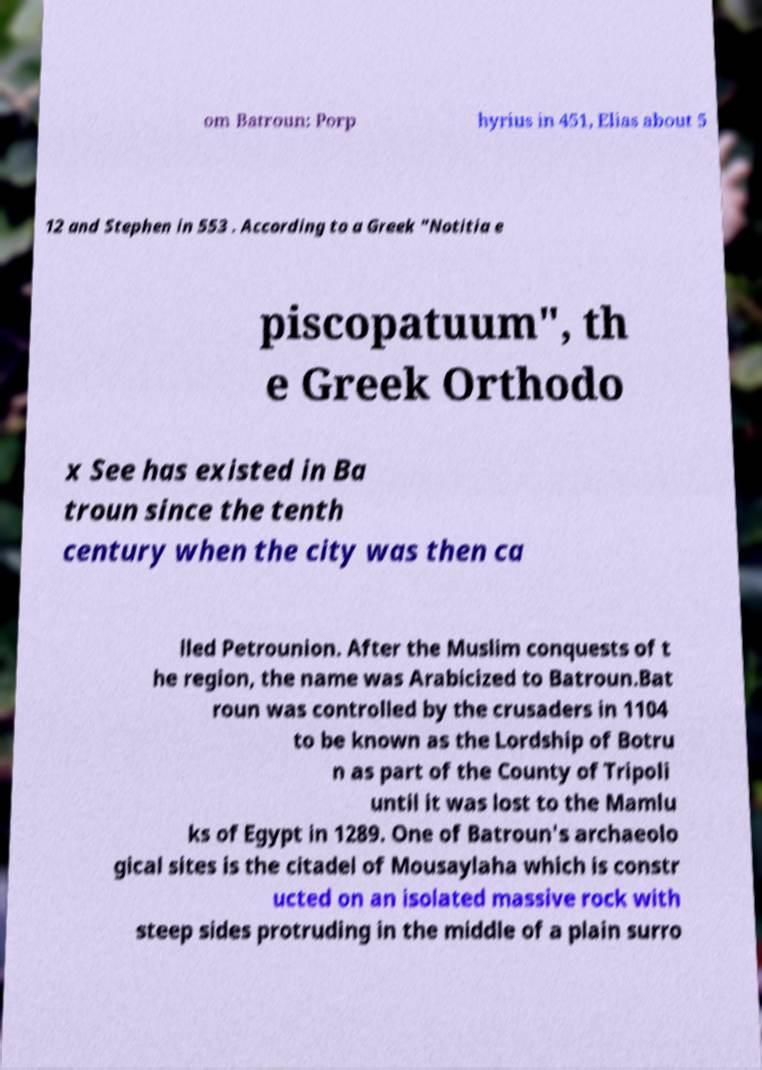Could you assist in decoding the text presented in this image and type it out clearly? om Batroun: Porp hyrius in 451, Elias about 5 12 and Stephen in 553 . According to a Greek "Notitia e piscopatuum", th e Greek Orthodo x See has existed in Ba troun since the tenth century when the city was then ca lled Petrounion. After the Muslim conquests of t he region, the name was Arabicized to Batroun.Bat roun was controlled by the crusaders in 1104 to be known as the Lordship of Botru n as part of the County of Tripoli until it was lost to the Mamlu ks of Egypt in 1289. One of Batroun's archaeolo gical sites is the citadel of Mousaylaha which is constr ucted on an isolated massive rock with steep sides protruding in the middle of a plain surro 